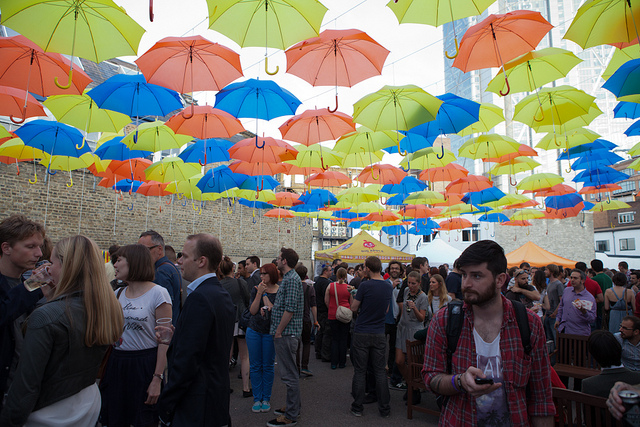<image>What culture is likely represented based on the items for sale on the wall? It is ambiguous what culture is likely represented based on the items for sale on the wall. It might be either Chinese, American, English, Veterans or Spanish. What culture is likely represented based on the items for sale on the wall? I don't know what culture is likely represented based on the items for sale on the wall. It can be Chinese, American, English, Veterans, or Spanish. 